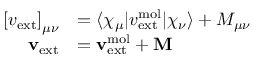Convert formula to latex. <formula><loc_0><loc_0><loc_500><loc_500>\begin{array} { r l } { \left [ v _ { e x t } \right ] _ { \mu \nu } } & { = \langle \chi _ { \mu } | v _ { e x t } ^ { m o l } | \chi _ { \nu } \rangle + M _ { \mu \nu } } \\ { v _ { e x t } } & { = v _ { e x t } ^ { m o l } + M } \end{array}</formula> 